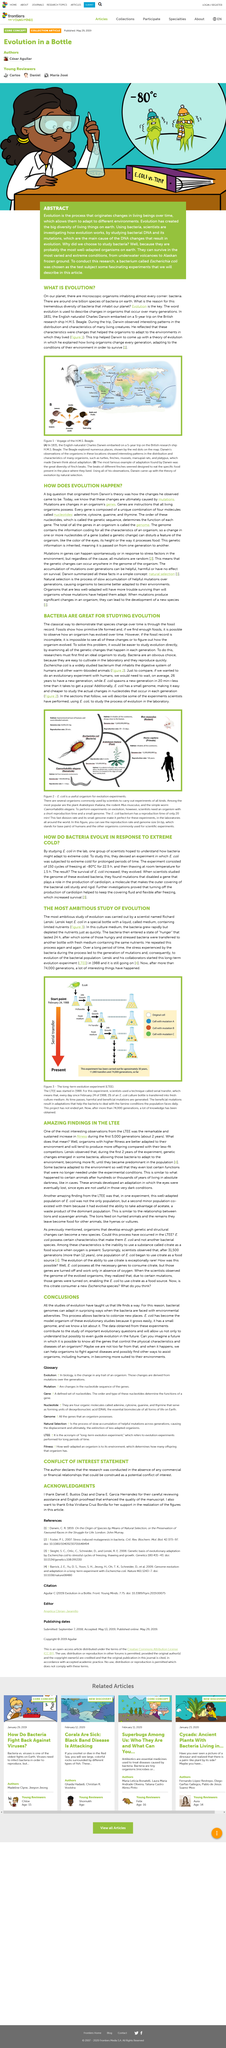Indicate a few pertinent items in this graphic. The Long Term Evolution Experiment began in 1988. Charles Darwin embarked on a historic five-year voyage that lasted for an extended period of time. Fossils demonstrate that primitive life was formed through the process of evolution, as evidenced by their ability to show the gradual transformation of organisms over time through the collection of adequate samples. The bacterial population evolved as a result of the mutations that occurred due to the stress caused by limited nutrients, which was experienced by the bacteria. Escherichia coli has a rapid reproduction rate of approximately 20 minutes. 